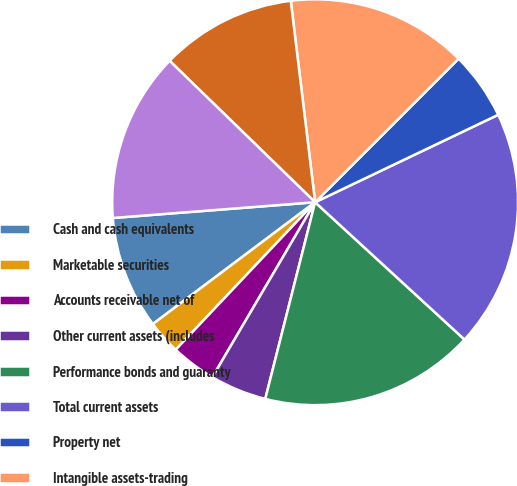<chart> <loc_0><loc_0><loc_500><loc_500><pie_chart><fcel>Cash and cash equivalents<fcel>Marketable securities<fcel>Accounts receivable net of<fcel>Other current assets (includes<fcel>Performance bonds and guaranty<fcel>Total current assets<fcel>Property net<fcel>Intangible assets-trading<fcel>Intangible assets-other net<fcel>Goodwill<nl><fcel>9.01%<fcel>2.7%<fcel>3.6%<fcel>4.5%<fcel>17.12%<fcel>18.92%<fcel>5.41%<fcel>14.41%<fcel>10.81%<fcel>13.51%<nl></chart> 